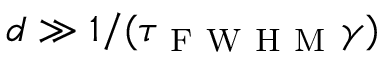<formula> <loc_0><loc_0><loc_500><loc_500>d \gg 1 / ( \tau _ { F W H M } \gamma )</formula> 